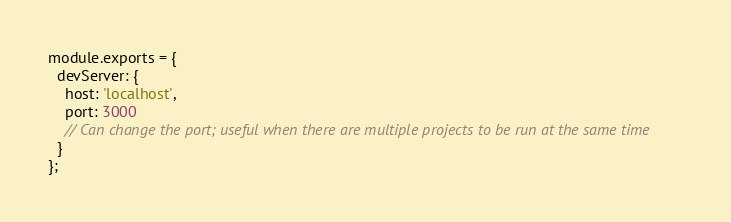Convert code to text. <code><loc_0><loc_0><loc_500><loc_500><_JavaScript_>module.exports = {
  devServer: {
    host: 'localhost',
    port: 3000
    // Can change the port; useful when there are multiple projects to be run at the same time
  }
};
</code> 